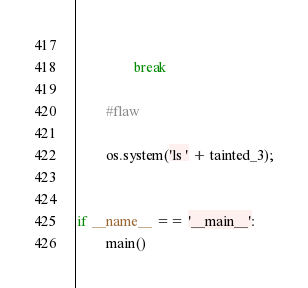<code> <loc_0><loc_0><loc_500><loc_500><_Python_>            
                break

        #flaw

        os.system('ls ' + tainted_3);
            

if __name__ == '__main__':
        main()</code> 